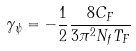Convert formula to latex. <formula><loc_0><loc_0><loc_500><loc_500>\gamma _ { \psi } = - \frac { 1 } { 2 } \frac { 8 C _ { F } } { 3 \pi ^ { 2 } N _ { f } T _ { F } }</formula> 